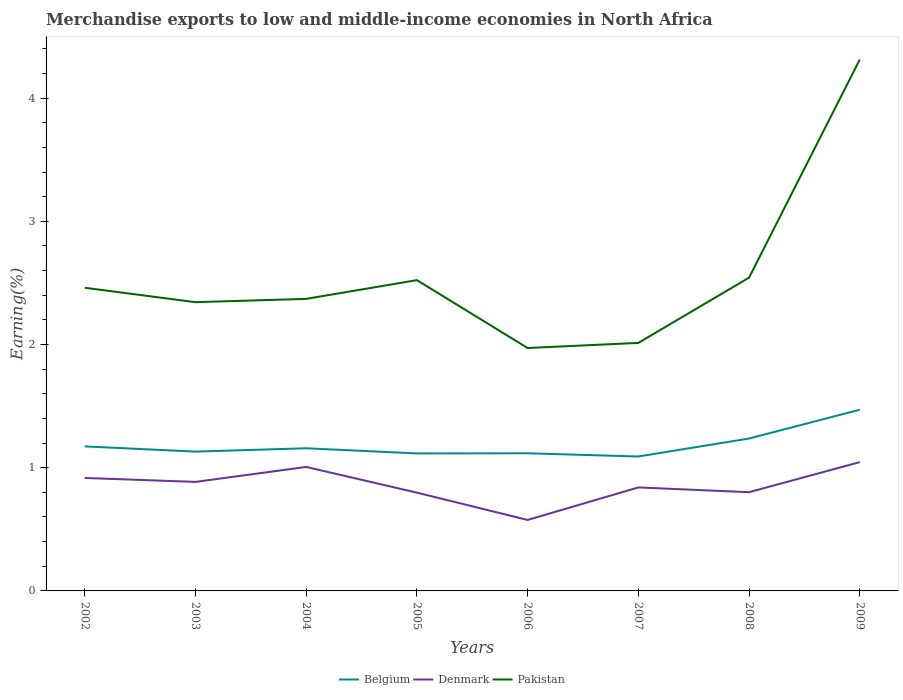How many different coloured lines are there?
Give a very brief answer. 3. Does the line corresponding to Belgium intersect with the line corresponding to Pakistan?
Provide a succinct answer. No. Is the number of lines equal to the number of legend labels?
Offer a very short reply. Yes. Across all years, what is the maximum percentage of amount earned from merchandise exports in Belgium?
Provide a succinct answer. 1.09. In which year was the percentage of amount earned from merchandise exports in Pakistan maximum?
Your answer should be very brief. 2006. What is the total percentage of amount earned from merchandise exports in Pakistan in the graph?
Ensure brevity in your answer.  -1.77. What is the difference between the highest and the second highest percentage of amount earned from merchandise exports in Pakistan?
Your response must be concise. 2.34. Is the percentage of amount earned from merchandise exports in Denmark strictly greater than the percentage of amount earned from merchandise exports in Belgium over the years?
Make the answer very short. Yes. How many lines are there?
Ensure brevity in your answer.  3. Are the values on the major ticks of Y-axis written in scientific E-notation?
Your response must be concise. No. Does the graph contain any zero values?
Offer a very short reply. No. Does the graph contain grids?
Make the answer very short. No. Where does the legend appear in the graph?
Provide a short and direct response. Bottom center. What is the title of the graph?
Your answer should be very brief. Merchandise exports to low and middle-income economies in North Africa. Does "Maldives" appear as one of the legend labels in the graph?
Provide a short and direct response. No. What is the label or title of the Y-axis?
Give a very brief answer. Earning(%). What is the Earning(%) in Belgium in 2002?
Keep it short and to the point. 1.17. What is the Earning(%) of Denmark in 2002?
Make the answer very short. 0.92. What is the Earning(%) of Pakistan in 2002?
Offer a very short reply. 2.46. What is the Earning(%) of Belgium in 2003?
Your answer should be compact. 1.13. What is the Earning(%) in Denmark in 2003?
Ensure brevity in your answer.  0.88. What is the Earning(%) of Pakistan in 2003?
Provide a short and direct response. 2.34. What is the Earning(%) of Belgium in 2004?
Provide a succinct answer. 1.16. What is the Earning(%) of Denmark in 2004?
Give a very brief answer. 1.01. What is the Earning(%) in Pakistan in 2004?
Offer a terse response. 2.37. What is the Earning(%) of Belgium in 2005?
Make the answer very short. 1.12. What is the Earning(%) of Denmark in 2005?
Offer a terse response. 0.8. What is the Earning(%) in Pakistan in 2005?
Offer a very short reply. 2.52. What is the Earning(%) of Belgium in 2006?
Keep it short and to the point. 1.12. What is the Earning(%) of Denmark in 2006?
Your response must be concise. 0.58. What is the Earning(%) of Pakistan in 2006?
Your answer should be very brief. 1.97. What is the Earning(%) of Belgium in 2007?
Give a very brief answer. 1.09. What is the Earning(%) in Denmark in 2007?
Offer a very short reply. 0.84. What is the Earning(%) in Pakistan in 2007?
Give a very brief answer. 2.01. What is the Earning(%) in Belgium in 2008?
Keep it short and to the point. 1.24. What is the Earning(%) of Denmark in 2008?
Give a very brief answer. 0.8. What is the Earning(%) in Pakistan in 2008?
Your response must be concise. 2.54. What is the Earning(%) in Belgium in 2009?
Ensure brevity in your answer.  1.47. What is the Earning(%) of Denmark in 2009?
Your answer should be very brief. 1.05. What is the Earning(%) of Pakistan in 2009?
Make the answer very short. 4.31. Across all years, what is the maximum Earning(%) of Belgium?
Provide a short and direct response. 1.47. Across all years, what is the maximum Earning(%) of Denmark?
Your answer should be compact. 1.05. Across all years, what is the maximum Earning(%) of Pakistan?
Your answer should be compact. 4.31. Across all years, what is the minimum Earning(%) of Belgium?
Your answer should be compact. 1.09. Across all years, what is the minimum Earning(%) in Denmark?
Keep it short and to the point. 0.58. Across all years, what is the minimum Earning(%) in Pakistan?
Your answer should be compact. 1.97. What is the total Earning(%) in Belgium in the graph?
Offer a terse response. 9.49. What is the total Earning(%) of Denmark in the graph?
Give a very brief answer. 6.87. What is the total Earning(%) in Pakistan in the graph?
Give a very brief answer. 20.54. What is the difference between the Earning(%) in Belgium in 2002 and that in 2003?
Make the answer very short. 0.04. What is the difference between the Earning(%) of Denmark in 2002 and that in 2003?
Keep it short and to the point. 0.03. What is the difference between the Earning(%) in Pakistan in 2002 and that in 2003?
Make the answer very short. 0.12. What is the difference between the Earning(%) of Belgium in 2002 and that in 2004?
Offer a terse response. 0.02. What is the difference between the Earning(%) in Denmark in 2002 and that in 2004?
Keep it short and to the point. -0.09. What is the difference between the Earning(%) of Pakistan in 2002 and that in 2004?
Your answer should be compact. 0.09. What is the difference between the Earning(%) of Belgium in 2002 and that in 2005?
Your response must be concise. 0.06. What is the difference between the Earning(%) of Denmark in 2002 and that in 2005?
Offer a terse response. 0.12. What is the difference between the Earning(%) in Pakistan in 2002 and that in 2005?
Offer a terse response. -0.06. What is the difference between the Earning(%) in Belgium in 2002 and that in 2006?
Your response must be concise. 0.06. What is the difference between the Earning(%) in Denmark in 2002 and that in 2006?
Ensure brevity in your answer.  0.34. What is the difference between the Earning(%) in Pakistan in 2002 and that in 2006?
Offer a terse response. 0.49. What is the difference between the Earning(%) of Belgium in 2002 and that in 2007?
Your response must be concise. 0.08. What is the difference between the Earning(%) of Denmark in 2002 and that in 2007?
Make the answer very short. 0.08. What is the difference between the Earning(%) of Pakistan in 2002 and that in 2007?
Make the answer very short. 0.45. What is the difference between the Earning(%) of Belgium in 2002 and that in 2008?
Provide a short and direct response. -0.06. What is the difference between the Earning(%) of Denmark in 2002 and that in 2008?
Your answer should be compact. 0.12. What is the difference between the Earning(%) in Pakistan in 2002 and that in 2008?
Keep it short and to the point. -0.08. What is the difference between the Earning(%) of Belgium in 2002 and that in 2009?
Your answer should be compact. -0.3. What is the difference between the Earning(%) in Denmark in 2002 and that in 2009?
Give a very brief answer. -0.13. What is the difference between the Earning(%) in Pakistan in 2002 and that in 2009?
Ensure brevity in your answer.  -1.85. What is the difference between the Earning(%) of Belgium in 2003 and that in 2004?
Make the answer very short. -0.03. What is the difference between the Earning(%) of Denmark in 2003 and that in 2004?
Provide a short and direct response. -0.12. What is the difference between the Earning(%) of Pakistan in 2003 and that in 2004?
Keep it short and to the point. -0.03. What is the difference between the Earning(%) of Belgium in 2003 and that in 2005?
Your response must be concise. 0.01. What is the difference between the Earning(%) in Denmark in 2003 and that in 2005?
Provide a succinct answer. 0.09. What is the difference between the Earning(%) of Pakistan in 2003 and that in 2005?
Keep it short and to the point. -0.18. What is the difference between the Earning(%) in Belgium in 2003 and that in 2006?
Give a very brief answer. 0.01. What is the difference between the Earning(%) in Denmark in 2003 and that in 2006?
Give a very brief answer. 0.31. What is the difference between the Earning(%) in Pakistan in 2003 and that in 2006?
Offer a terse response. 0.37. What is the difference between the Earning(%) in Belgium in 2003 and that in 2007?
Provide a succinct answer. 0.04. What is the difference between the Earning(%) of Denmark in 2003 and that in 2007?
Your answer should be very brief. 0.04. What is the difference between the Earning(%) in Pakistan in 2003 and that in 2007?
Offer a terse response. 0.33. What is the difference between the Earning(%) of Belgium in 2003 and that in 2008?
Ensure brevity in your answer.  -0.11. What is the difference between the Earning(%) in Denmark in 2003 and that in 2008?
Provide a short and direct response. 0.08. What is the difference between the Earning(%) in Pakistan in 2003 and that in 2008?
Give a very brief answer. -0.2. What is the difference between the Earning(%) of Belgium in 2003 and that in 2009?
Offer a very short reply. -0.34. What is the difference between the Earning(%) of Denmark in 2003 and that in 2009?
Your answer should be very brief. -0.16. What is the difference between the Earning(%) of Pakistan in 2003 and that in 2009?
Offer a terse response. -1.97. What is the difference between the Earning(%) in Belgium in 2004 and that in 2005?
Give a very brief answer. 0.04. What is the difference between the Earning(%) in Denmark in 2004 and that in 2005?
Keep it short and to the point. 0.21. What is the difference between the Earning(%) of Pakistan in 2004 and that in 2005?
Make the answer very short. -0.15. What is the difference between the Earning(%) of Belgium in 2004 and that in 2006?
Your answer should be compact. 0.04. What is the difference between the Earning(%) of Denmark in 2004 and that in 2006?
Offer a terse response. 0.43. What is the difference between the Earning(%) in Pakistan in 2004 and that in 2006?
Your response must be concise. 0.4. What is the difference between the Earning(%) in Belgium in 2004 and that in 2007?
Make the answer very short. 0.07. What is the difference between the Earning(%) of Denmark in 2004 and that in 2007?
Offer a very short reply. 0.17. What is the difference between the Earning(%) of Pakistan in 2004 and that in 2007?
Provide a succinct answer. 0.36. What is the difference between the Earning(%) of Belgium in 2004 and that in 2008?
Make the answer very short. -0.08. What is the difference between the Earning(%) in Denmark in 2004 and that in 2008?
Make the answer very short. 0.2. What is the difference between the Earning(%) in Pakistan in 2004 and that in 2008?
Make the answer very short. -0.17. What is the difference between the Earning(%) in Belgium in 2004 and that in 2009?
Ensure brevity in your answer.  -0.31. What is the difference between the Earning(%) in Denmark in 2004 and that in 2009?
Offer a terse response. -0.04. What is the difference between the Earning(%) in Pakistan in 2004 and that in 2009?
Your answer should be very brief. -1.94. What is the difference between the Earning(%) in Belgium in 2005 and that in 2006?
Your answer should be very brief. -0. What is the difference between the Earning(%) in Denmark in 2005 and that in 2006?
Provide a short and direct response. 0.22. What is the difference between the Earning(%) of Pakistan in 2005 and that in 2006?
Ensure brevity in your answer.  0.55. What is the difference between the Earning(%) in Belgium in 2005 and that in 2007?
Offer a terse response. 0.02. What is the difference between the Earning(%) of Denmark in 2005 and that in 2007?
Your response must be concise. -0.04. What is the difference between the Earning(%) in Pakistan in 2005 and that in 2007?
Make the answer very short. 0.51. What is the difference between the Earning(%) of Belgium in 2005 and that in 2008?
Your response must be concise. -0.12. What is the difference between the Earning(%) in Denmark in 2005 and that in 2008?
Give a very brief answer. -0. What is the difference between the Earning(%) in Pakistan in 2005 and that in 2008?
Provide a succinct answer. -0.02. What is the difference between the Earning(%) of Belgium in 2005 and that in 2009?
Offer a very short reply. -0.35. What is the difference between the Earning(%) of Denmark in 2005 and that in 2009?
Give a very brief answer. -0.25. What is the difference between the Earning(%) in Pakistan in 2005 and that in 2009?
Offer a terse response. -1.79. What is the difference between the Earning(%) in Belgium in 2006 and that in 2007?
Make the answer very short. 0.03. What is the difference between the Earning(%) of Denmark in 2006 and that in 2007?
Make the answer very short. -0.26. What is the difference between the Earning(%) of Pakistan in 2006 and that in 2007?
Provide a succinct answer. -0.04. What is the difference between the Earning(%) in Belgium in 2006 and that in 2008?
Your answer should be very brief. -0.12. What is the difference between the Earning(%) of Denmark in 2006 and that in 2008?
Keep it short and to the point. -0.23. What is the difference between the Earning(%) of Pakistan in 2006 and that in 2008?
Offer a terse response. -0.57. What is the difference between the Earning(%) in Belgium in 2006 and that in 2009?
Keep it short and to the point. -0.35. What is the difference between the Earning(%) in Denmark in 2006 and that in 2009?
Provide a short and direct response. -0.47. What is the difference between the Earning(%) of Pakistan in 2006 and that in 2009?
Provide a short and direct response. -2.34. What is the difference between the Earning(%) of Belgium in 2007 and that in 2008?
Provide a short and direct response. -0.15. What is the difference between the Earning(%) in Denmark in 2007 and that in 2008?
Your answer should be compact. 0.04. What is the difference between the Earning(%) of Pakistan in 2007 and that in 2008?
Ensure brevity in your answer.  -0.53. What is the difference between the Earning(%) in Belgium in 2007 and that in 2009?
Your response must be concise. -0.38. What is the difference between the Earning(%) in Denmark in 2007 and that in 2009?
Provide a succinct answer. -0.21. What is the difference between the Earning(%) of Pakistan in 2007 and that in 2009?
Offer a very short reply. -2.3. What is the difference between the Earning(%) of Belgium in 2008 and that in 2009?
Your answer should be very brief. -0.23. What is the difference between the Earning(%) in Denmark in 2008 and that in 2009?
Provide a short and direct response. -0.24. What is the difference between the Earning(%) in Pakistan in 2008 and that in 2009?
Your response must be concise. -1.77. What is the difference between the Earning(%) of Belgium in 2002 and the Earning(%) of Denmark in 2003?
Provide a short and direct response. 0.29. What is the difference between the Earning(%) in Belgium in 2002 and the Earning(%) in Pakistan in 2003?
Provide a short and direct response. -1.17. What is the difference between the Earning(%) in Denmark in 2002 and the Earning(%) in Pakistan in 2003?
Your answer should be compact. -1.43. What is the difference between the Earning(%) of Belgium in 2002 and the Earning(%) of Denmark in 2004?
Keep it short and to the point. 0.17. What is the difference between the Earning(%) in Belgium in 2002 and the Earning(%) in Pakistan in 2004?
Provide a succinct answer. -1.2. What is the difference between the Earning(%) in Denmark in 2002 and the Earning(%) in Pakistan in 2004?
Offer a very short reply. -1.45. What is the difference between the Earning(%) of Belgium in 2002 and the Earning(%) of Denmark in 2005?
Make the answer very short. 0.38. What is the difference between the Earning(%) of Belgium in 2002 and the Earning(%) of Pakistan in 2005?
Your answer should be very brief. -1.35. What is the difference between the Earning(%) of Denmark in 2002 and the Earning(%) of Pakistan in 2005?
Ensure brevity in your answer.  -1.61. What is the difference between the Earning(%) in Belgium in 2002 and the Earning(%) in Denmark in 2006?
Your response must be concise. 0.6. What is the difference between the Earning(%) of Belgium in 2002 and the Earning(%) of Pakistan in 2006?
Provide a short and direct response. -0.8. What is the difference between the Earning(%) in Denmark in 2002 and the Earning(%) in Pakistan in 2006?
Make the answer very short. -1.05. What is the difference between the Earning(%) of Belgium in 2002 and the Earning(%) of Denmark in 2007?
Provide a succinct answer. 0.33. What is the difference between the Earning(%) of Belgium in 2002 and the Earning(%) of Pakistan in 2007?
Your answer should be very brief. -0.84. What is the difference between the Earning(%) in Denmark in 2002 and the Earning(%) in Pakistan in 2007?
Your answer should be compact. -1.1. What is the difference between the Earning(%) of Belgium in 2002 and the Earning(%) of Denmark in 2008?
Ensure brevity in your answer.  0.37. What is the difference between the Earning(%) in Belgium in 2002 and the Earning(%) in Pakistan in 2008?
Provide a succinct answer. -1.37. What is the difference between the Earning(%) in Denmark in 2002 and the Earning(%) in Pakistan in 2008?
Make the answer very short. -1.63. What is the difference between the Earning(%) in Belgium in 2002 and the Earning(%) in Denmark in 2009?
Make the answer very short. 0.13. What is the difference between the Earning(%) of Belgium in 2002 and the Earning(%) of Pakistan in 2009?
Keep it short and to the point. -3.14. What is the difference between the Earning(%) in Denmark in 2002 and the Earning(%) in Pakistan in 2009?
Your answer should be very brief. -3.4. What is the difference between the Earning(%) in Belgium in 2003 and the Earning(%) in Denmark in 2004?
Give a very brief answer. 0.12. What is the difference between the Earning(%) in Belgium in 2003 and the Earning(%) in Pakistan in 2004?
Ensure brevity in your answer.  -1.24. What is the difference between the Earning(%) in Denmark in 2003 and the Earning(%) in Pakistan in 2004?
Offer a terse response. -1.49. What is the difference between the Earning(%) of Belgium in 2003 and the Earning(%) of Denmark in 2005?
Ensure brevity in your answer.  0.33. What is the difference between the Earning(%) in Belgium in 2003 and the Earning(%) in Pakistan in 2005?
Your answer should be compact. -1.39. What is the difference between the Earning(%) in Denmark in 2003 and the Earning(%) in Pakistan in 2005?
Ensure brevity in your answer.  -1.64. What is the difference between the Earning(%) of Belgium in 2003 and the Earning(%) of Denmark in 2006?
Make the answer very short. 0.55. What is the difference between the Earning(%) in Belgium in 2003 and the Earning(%) in Pakistan in 2006?
Keep it short and to the point. -0.84. What is the difference between the Earning(%) in Denmark in 2003 and the Earning(%) in Pakistan in 2006?
Make the answer very short. -1.09. What is the difference between the Earning(%) in Belgium in 2003 and the Earning(%) in Denmark in 2007?
Provide a short and direct response. 0.29. What is the difference between the Earning(%) of Belgium in 2003 and the Earning(%) of Pakistan in 2007?
Offer a terse response. -0.88. What is the difference between the Earning(%) of Denmark in 2003 and the Earning(%) of Pakistan in 2007?
Ensure brevity in your answer.  -1.13. What is the difference between the Earning(%) of Belgium in 2003 and the Earning(%) of Denmark in 2008?
Your response must be concise. 0.33. What is the difference between the Earning(%) of Belgium in 2003 and the Earning(%) of Pakistan in 2008?
Offer a terse response. -1.41. What is the difference between the Earning(%) of Denmark in 2003 and the Earning(%) of Pakistan in 2008?
Your answer should be very brief. -1.66. What is the difference between the Earning(%) of Belgium in 2003 and the Earning(%) of Denmark in 2009?
Your answer should be compact. 0.09. What is the difference between the Earning(%) of Belgium in 2003 and the Earning(%) of Pakistan in 2009?
Provide a short and direct response. -3.18. What is the difference between the Earning(%) in Denmark in 2003 and the Earning(%) in Pakistan in 2009?
Your answer should be very brief. -3.43. What is the difference between the Earning(%) of Belgium in 2004 and the Earning(%) of Denmark in 2005?
Ensure brevity in your answer.  0.36. What is the difference between the Earning(%) in Belgium in 2004 and the Earning(%) in Pakistan in 2005?
Keep it short and to the point. -1.36. What is the difference between the Earning(%) of Denmark in 2004 and the Earning(%) of Pakistan in 2005?
Offer a very short reply. -1.52. What is the difference between the Earning(%) in Belgium in 2004 and the Earning(%) in Denmark in 2006?
Provide a succinct answer. 0.58. What is the difference between the Earning(%) of Belgium in 2004 and the Earning(%) of Pakistan in 2006?
Your answer should be compact. -0.81. What is the difference between the Earning(%) in Denmark in 2004 and the Earning(%) in Pakistan in 2006?
Provide a succinct answer. -0.97. What is the difference between the Earning(%) in Belgium in 2004 and the Earning(%) in Denmark in 2007?
Provide a short and direct response. 0.32. What is the difference between the Earning(%) in Belgium in 2004 and the Earning(%) in Pakistan in 2007?
Provide a short and direct response. -0.86. What is the difference between the Earning(%) in Denmark in 2004 and the Earning(%) in Pakistan in 2007?
Offer a very short reply. -1.01. What is the difference between the Earning(%) in Belgium in 2004 and the Earning(%) in Denmark in 2008?
Offer a terse response. 0.36. What is the difference between the Earning(%) of Belgium in 2004 and the Earning(%) of Pakistan in 2008?
Make the answer very short. -1.38. What is the difference between the Earning(%) of Denmark in 2004 and the Earning(%) of Pakistan in 2008?
Make the answer very short. -1.54. What is the difference between the Earning(%) of Belgium in 2004 and the Earning(%) of Denmark in 2009?
Make the answer very short. 0.11. What is the difference between the Earning(%) of Belgium in 2004 and the Earning(%) of Pakistan in 2009?
Your response must be concise. -3.15. What is the difference between the Earning(%) in Denmark in 2004 and the Earning(%) in Pakistan in 2009?
Your answer should be compact. -3.31. What is the difference between the Earning(%) of Belgium in 2005 and the Earning(%) of Denmark in 2006?
Give a very brief answer. 0.54. What is the difference between the Earning(%) of Belgium in 2005 and the Earning(%) of Pakistan in 2006?
Offer a very short reply. -0.86. What is the difference between the Earning(%) of Denmark in 2005 and the Earning(%) of Pakistan in 2006?
Offer a terse response. -1.17. What is the difference between the Earning(%) in Belgium in 2005 and the Earning(%) in Denmark in 2007?
Offer a very short reply. 0.28. What is the difference between the Earning(%) in Belgium in 2005 and the Earning(%) in Pakistan in 2007?
Ensure brevity in your answer.  -0.9. What is the difference between the Earning(%) in Denmark in 2005 and the Earning(%) in Pakistan in 2007?
Your answer should be very brief. -1.22. What is the difference between the Earning(%) in Belgium in 2005 and the Earning(%) in Denmark in 2008?
Give a very brief answer. 0.31. What is the difference between the Earning(%) of Belgium in 2005 and the Earning(%) of Pakistan in 2008?
Keep it short and to the point. -1.43. What is the difference between the Earning(%) in Denmark in 2005 and the Earning(%) in Pakistan in 2008?
Offer a terse response. -1.74. What is the difference between the Earning(%) in Belgium in 2005 and the Earning(%) in Denmark in 2009?
Your answer should be compact. 0.07. What is the difference between the Earning(%) in Belgium in 2005 and the Earning(%) in Pakistan in 2009?
Ensure brevity in your answer.  -3.2. What is the difference between the Earning(%) of Denmark in 2005 and the Earning(%) of Pakistan in 2009?
Provide a short and direct response. -3.51. What is the difference between the Earning(%) in Belgium in 2006 and the Earning(%) in Denmark in 2007?
Offer a very short reply. 0.28. What is the difference between the Earning(%) of Belgium in 2006 and the Earning(%) of Pakistan in 2007?
Provide a succinct answer. -0.9. What is the difference between the Earning(%) in Denmark in 2006 and the Earning(%) in Pakistan in 2007?
Your answer should be compact. -1.44. What is the difference between the Earning(%) in Belgium in 2006 and the Earning(%) in Denmark in 2008?
Give a very brief answer. 0.32. What is the difference between the Earning(%) of Belgium in 2006 and the Earning(%) of Pakistan in 2008?
Your answer should be compact. -1.43. What is the difference between the Earning(%) of Denmark in 2006 and the Earning(%) of Pakistan in 2008?
Your answer should be very brief. -1.97. What is the difference between the Earning(%) of Belgium in 2006 and the Earning(%) of Denmark in 2009?
Your response must be concise. 0.07. What is the difference between the Earning(%) of Belgium in 2006 and the Earning(%) of Pakistan in 2009?
Offer a very short reply. -3.2. What is the difference between the Earning(%) of Denmark in 2006 and the Earning(%) of Pakistan in 2009?
Offer a terse response. -3.74. What is the difference between the Earning(%) in Belgium in 2007 and the Earning(%) in Denmark in 2008?
Make the answer very short. 0.29. What is the difference between the Earning(%) in Belgium in 2007 and the Earning(%) in Pakistan in 2008?
Offer a terse response. -1.45. What is the difference between the Earning(%) in Denmark in 2007 and the Earning(%) in Pakistan in 2008?
Offer a terse response. -1.7. What is the difference between the Earning(%) of Belgium in 2007 and the Earning(%) of Denmark in 2009?
Give a very brief answer. 0.05. What is the difference between the Earning(%) of Belgium in 2007 and the Earning(%) of Pakistan in 2009?
Provide a short and direct response. -3.22. What is the difference between the Earning(%) in Denmark in 2007 and the Earning(%) in Pakistan in 2009?
Give a very brief answer. -3.47. What is the difference between the Earning(%) of Belgium in 2008 and the Earning(%) of Denmark in 2009?
Keep it short and to the point. 0.19. What is the difference between the Earning(%) in Belgium in 2008 and the Earning(%) in Pakistan in 2009?
Give a very brief answer. -3.08. What is the difference between the Earning(%) in Denmark in 2008 and the Earning(%) in Pakistan in 2009?
Your answer should be compact. -3.51. What is the average Earning(%) of Belgium per year?
Provide a short and direct response. 1.19. What is the average Earning(%) of Denmark per year?
Your answer should be very brief. 0.86. What is the average Earning(%) of Pakistan per year?
Provide a short and direct response. 2.57. In the year 2002, what is the difference between the Earning(%) of Belgium and Earning(%) of Denmark?
Ensure brevity in your answer.  0.26. In the year 2002, what is the difference between the Earning(%) in Belgium and Earning(%) in Pakistan?
Your response must be concise. -1.29. In the year 2002, what is the difference between the Earning(%) of Denmark and Earning(%) of Pakistan?
Your response must be concise. -1.54. In the year 2003, what is the difference between the Earning(%) of Belgium and Earning(%) of Denmark?
Make the answer very short. 0.25. In the year 2003, what is the difference between the Earning(%) of Belgium and Earning(%) of Pakistan?
Your response must be concise. -1.21. In the year 2003, what is the difference between the Earning(%) of Denmark and Earning(%) of Pakistan?
Provide a succinct answer. -1.46. In the year 2004, what is the difference between the Earning(%) of Belgium and Earning(%) of Denmark?
Your answer should be very brief. 0.15. In the year 2004, what is the difference between the Earning(%) in Belgium and Earning(%) in Pakistan?
Your answer should be very brief. -1.21. In the year 2004, what is the difference between the Earning(%) of Denmark and Earning(%) of Pakistan?
Your answer should be very brief. -1.36. In the year 2005, what is the difference between the Earning(%) of Belgium and Earning(%) of Denmark?
Provide a succinct answer. 0.32. In the year 2005, what is the difference between the Earning(%) of Belgium and Earning(%) of Pakistan?
Your answer should be compact. -1.41. In the year 2005, what is the difference between the Earning(%) of Denmark and Earning(%) of Pakistan?
Your answer should be very brief. -1.73. In the year 2006, what is the difference between the Earning(%) in Belgium and Earning(%) in Denmark?
Ensure brevity in your answer.  0.54. In the year 2006, what is the difference between the Earning(%) of Belgium and Earning(%) of Pakistan?
Ensure brevity in your answer.  -0.85. In the year 2006, what is the difference between the Earning(%) of Denmark and Earning(%) of Pakistan?
Provide a short and direct response. -1.4. In the year 2007, what is the difference between the Earning(%) in Belgium and Earning(%) in Denmark?
Your response must be concise. 0.25. In the year 2007, what is the difference between the Earning(%) in Belgium and Earning(%) in Pakistan?
Keep it short and to the point. -0.92. In the year 2007, what is the difference between the Earning(%) of Denmark and Earning(%) of Pakistan?
Your answer should be compact. -1.17. In the year 2008, what is the difference between the Earning(%) of Belgium and Earning(%) of Denmark?
Offer a terse response. 0.44. In the year 2008, what is the difference between the Earning(%) in Belgium and Earning(%) in Pakistan?
Offer a very short reply. -1.31. In the year 2008, what is the difference between the Earning(%) in Denmark and Earning(%) in Pakistan?
Offer a terse response. -1.74. In the year 2009, what is the difference between the Earning(%) in Belgium and Earning(%) in Denmark?
Ensure brevity in your answer.  0.43. In the year 2009, what is the difference between the Earning(%) of Belgium and Earning(%) of Pakistan?
Make the answer very short. -2.84. In the year 2009, what is the difference between the Earning(%) of Denmark and Earning(%) of Pakistan?
Your answer should be compact. -3.27. What is the ratio of the Earning(%) in Belgium in 2002 to that in 2003?
Give a very brief answer. 1.04. What is the ratio of the Earning(%) of Denmark in 2002 to that in 2003?
Make the answer very short. 1.04. What is the ratio of the Earning(%) in Pakistan in 2002 to that in 2003?
Keep it short and to the point. 1.05. What is the ratio of the Earning(%) in Belgium in 2002 to that in 2004?
Provide a succinct answer. 1.01. What is the ratio of the Earning(%) in Denmark in 2002 to that in 2004?
Provide a short and direct response. 0.91. What is the ratio of the Earning(%) of Pakistan in 2002 to that in 2004?
Make the answer very short. 1.04. What is the ratio of the Earning(%) in Belgium in 2002 to that in 2005?
Your answer should be compact. 1.05. What is the ratio of the Earning(%) in Denmark in 2002 to that in 2005?
Offer a very short reply. 1.15. What is the ratio of the Earning(%) in Pakistan in 2002 to that in 2005?
Offer a very short reply. 0.98. What is the ratio of the Earning(%) of Belgium in 2002 to that in 2006?
Offer a terse response. 1.05. What is the ratio of the Earning(%) in Denmark in 2002 to that in 2006?
Ensure brevity in your answer.  1.59. What is the ratio of the Earning(%) of Pakistan in 2002 to that in 2006?
Your answer should be very brief. 1.25. What is the ratio of the Earning(%) of Belgium in 2002 to that in 2007?
Make the answer very short. 1.08. What is the ratio of the Earning(%) in Denmark in 2002 to that in 2007?
Give a very brief answer. 1.09. What is the ratio of the Earning(%) in Pakistan in 2002 to that in 2007?
Provide a succinct answer. 1.22. What is the ratio of the Earning(%) of Belgium in 2002 to that in 2008?
Your response must be concise. 0.95. What is the ratio of the Earning(%) of Denmark in 2002 to that in 2008?
Your response must be concise. 1.14. What is the ratio of the Earning(%) in Pakistan in 2002 to that in 2008?
Your answer should be very brief. 0.97. What is the ratio of the Earning(%) in Belgium in 2002 to that in 2009?
Make the answer very short. 0.8. What is the ratio of the Earning(%) in Denmark in 2002 to that in 2009?
Your answer should be very brief. 0.88. What is the ratio of the Earning(%) of Pakistan in 2002 to that in 2009?
Provide a succinct answer. 0.57. What is the ratio of the Earning(%) in Belgium in 2003 to that in 2004?
Offer a terse response. 0.98. What is the ratio of the Earning(%) in Denmark in 2003 to that in 2004?
Your answer should be very brief. 0.88. What is the ratio of the Earning(%) in Pakistan in 2003 to that in 2004?
Provide a succinct answer. 0.99. What is the ratio of the Earning(%) in Belgium in 2003 to that in 2005?
Offer a very short reply. 1.01. What is the ratio of the Earning(%) in Denmark in 2003 to that in 2005?
Your response must be concise. 1.11. What is the ratio of the Earning(%) in Pakistan in 2003 to that in 2005?
Give a very brief answer. 0.93. What is the ratio of the Earning(%) of Belgium in 2003 to that in 2006?
Make the answer very short. 1.01. What is the ratio of the Earning(%) of Denmark in 2003 to that in 2006?
Your response must be concise. 1.54. What is the ratio of the Earning(%) of Pakistan in 2003 to that in 2006?
Provide a short and direct response. 1.19. What is the ratio of the Earning(%) in Belgium in 2003 to that in 2007?
Offer a terse response. 1.04. What is the ratio of the Earning(%) of Denmark in 2003 to that in 2007?
Offer a very short reply. 1.05. What is the ratio of the Earning(%) of Pakistan in 2003 to that in 2007?
Ensure brevity in your answer.  1.16. What is the ratio of the Earning(%) in Belgium in 2003 to that in 2008?
Make the answer very short. 0.91. What is the ratio of the Earning(%) in Denmark in 2003 to that in 2008?
Your answer should be very brief. 1.1. What is the ratio of the Earning(%) of Pakistan in 2003 to that in 2008?
Provide a short and direct response. 0.92. What is the ratio of the Earning(%) of Belgium in 2003 to that in 2009?
Make the answer very short. 0.77. What is the ratio of the Earning(%) in Denmark in 2003 to that in 2009?
Offer a terse response. 0.85. What is the ratio of the Earning(%) of Pakistan in 2003 to that in 2009?
Provide a short and direct response. 0.54. What is the ratio of the Earning(%) in Belgium in 2004 to that in 2005?
Your answer should be very brief. 1.04. What is the ratio of the Earning(%) of Denmark in 2004 to that in 2005?
Your response must be concise. 1.26. What is the ratio of the Earning(%) in Pakistan in 2004 to that in 2005?
Your answer should be very brief. 0.94. What is the ratio of the Earning(%) of Belgium in 2004 to that in 2006?
Offer a terse response. 1.04. What is the ratio of the Earning(%) in Denmark in 2004 to that in 2006?
Your response must be concise. 1.75. What is the ratio of the Earning(%) in Pakistan in 2004 to that in 2006?
Provide a succinct answer. 1.2. What is the ratio of the Earning(%) in Belgium in 2004 to that in 2007?
Keep it short and to the point. 1.06. What is the ratio of the Earning(%) in Denmark in 2004 to that in 2007?
Your response must be concise. 1.2. What is the ratio of the Earning(%) of Pakistan in 2004 to that in 2007?
Your response must be concise. 1.18. What is the ratio of the Earning(%) of Belgium in 2004 to that in 2008?
Offer a very short reply. 0.94. What is the ratio of the Earning(%) in Denmark in 2004 to that in 2008?
Your answer should be very brief. 1.26. What is the ratio of the Earning(%) of Pakistan in 2004 to that in 2008?
Provide a short and direct response. 0.93. What is the ratio of the Earning(%) in Belgium in 2004 to that in 2009?
Ensure brevity in your answer.  0.79. What is the ratio of the Earning(%) in Denmark in 2004 to that in 2009?
Ensure brevity in your answer.  0.96. What is the ratio of the Earning(%) of Pakistan in 2004 to that in 2009?
Offer a terse response. 0.55. What is the ratio of the Earning(%) in Denmark in 2005 to that in 2006?
Keep it short and to the point. 1.38. What is the ratio of the Earning(%) in Pakistan in 2005 to that in 2006?
Your answer should be compact. 1.28. What is the ratio of the Earning(%) in Belgium in 2005 to that in 2007?
Provide a short and direct response. 1.02. What is the ratio of the Earning(%) of Denmark in 2005 to that in 2007?
Provide a succinct answer. 0.95. What is the ratio of the Earning(%) in Pakistan in 2005 to that in 2007?
Provide a short and direct response. 1.25. What is the ratio of the Earning(%) of Belgium in 2005 to that in 2008?
Give a very brief answer. 0.9. What is the ratio of the Earning(%) of Denmark in 2005 to that in 2008?
Keep it short and to the point. 1. What is the ratio of the Earning(%) of Belgium in 2005 to that in 2009?
Provide a short and direct response. 0.76. What is the ratio of the Earning(%) of Denmark in 2005 to that in 2009?
Offer a terse response. 0.76. What is the ratio of the Earning(%) of Pakistan in 2005 to that in 2009?
Provide a short and direct response. 0.58. What is the ratio of the Earning(%) of Belgium in 2006 to that in 2007?
Provide a succinct answer. 1.02. What is the ratio of the Earning(%) in Denmark in 2006 to that in 2007?
Ensure brevity in your answer.  0.69. What is the ratio of the Earning(%) of Pakistan in 2006 to that in 2007?
Give a very brief answer. 0.98. What is the ratio of the Earning(%) of Belgium in 2006 to that in 2008?
Provide a succinct answer. 0.9. What is the ratio of the Earning(%) in Denmark in 2006 to that in 2008?
Offer a terse response. 0.72. What is the ratio of the Earning(%) of Pakistan in 2006 to that in 2008?
Provide a short and direct response. 0.78. What is the ratio of the Earning(%) of Belgium in 2006 to that in 2009?
Offer a terse response. 0.76. What is the ratio of the Earning(%) in Denmark in 2006 to that in 2009?
Provide a short and direct response. 0.55. What is the ratio of the Earning(%) of Pakistan in 2006 to that in 2009?
Provide a succinct answer. 0.46. What is the ratio of the Earning(%) of Belgium in 2007 to that in 2008?
Provide a short and direct response. 0.88. What is the ratio of the Earning(%) in Denmark in 2007 to that in 2008?
Provide a succinct answer. 1.05. What is the ratio of the Earning(%) in Pakistan in 2007 to that in 2008?
Offer a very short reply. 0.79. What is the ratio of the Earning(%) in Belgium in 2007 to that in 2009?
Offer a terse response. 0.74. What is the ratio of the Earning(%) in Denmark in 2007 to that in 2009?
Give a very brief answer. 0.8. What is the ratio of the Earning(%) of Pakistan in 2007 to that in 2009?
Keep it short and to the point. 0.47. What is the ratio of the Earning(%) of Belgium in 2008 to that in 2009?
Give a very brief answer. 0.84. What is the ratio of the Earning(%) of Denmark in 2008 to that in 2009?
Give a very brief answer. 0.77. What is the ratio of the Earning(%) in Pakistan in 2008 to that in 2009?
Make the answer very short. 0.59. What is the difference between the highest and the second highest Earning(%) in Belgium?
Your answer should be very brief. 0.23. What is the difference between the highest and the second highest Earning(%) of Denmark?
Offer a very short reply. 0.04. What is the difference between the highest and the second highest Earning(%) in Pakistan?
Provide a short and direct response. 1.77. What is the difference between the highest and the lowest Earning(%) in Belgium?
Offer a terse response. 0.38. What is the difference between the highest and the lowest Earning(%) in Denmark?
Your response must be concise. 0.47. What is the difference between the highest and the lowest Earning(%) in Pakistan?
Your answer should be very brief. 2.34. 